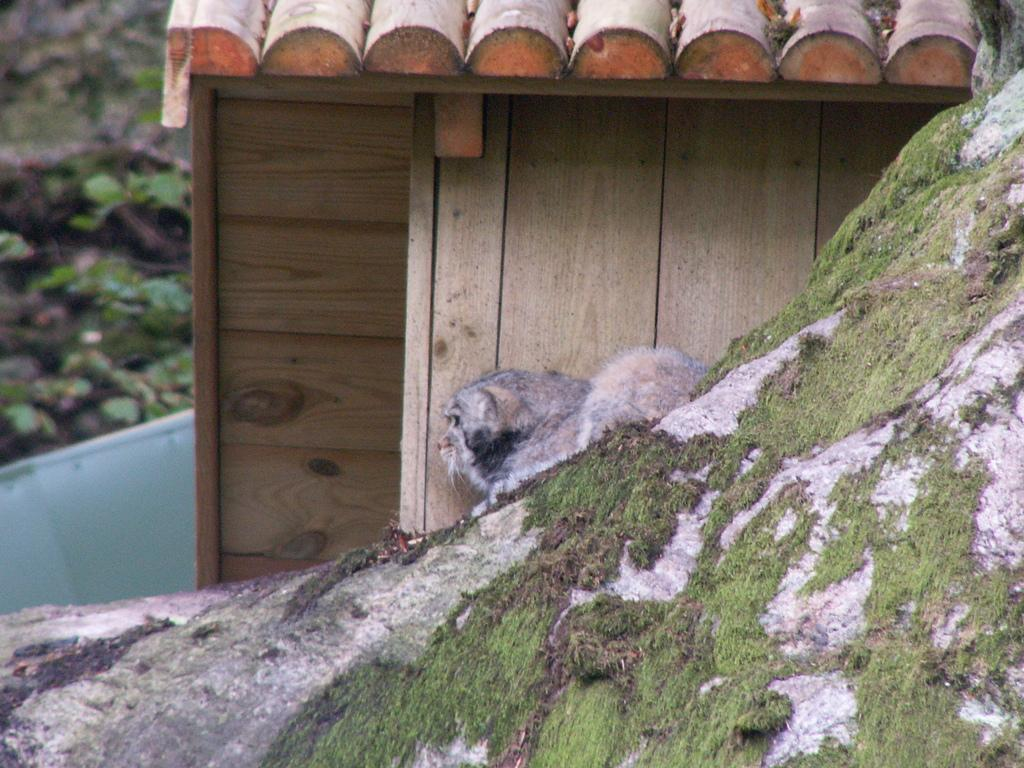What is the main subject in the center of the image? There is a dog in the center of the image. Where is the dog located? The dog is on a rock. What type of structure can be seen at the top side of the image? There is a roof visible at the top side of the image. What type of shoes is the governor wearing on his feet in the image? There is no governor or shoes present in the image; it features a dog on a rock with a roof visible at the top side. 